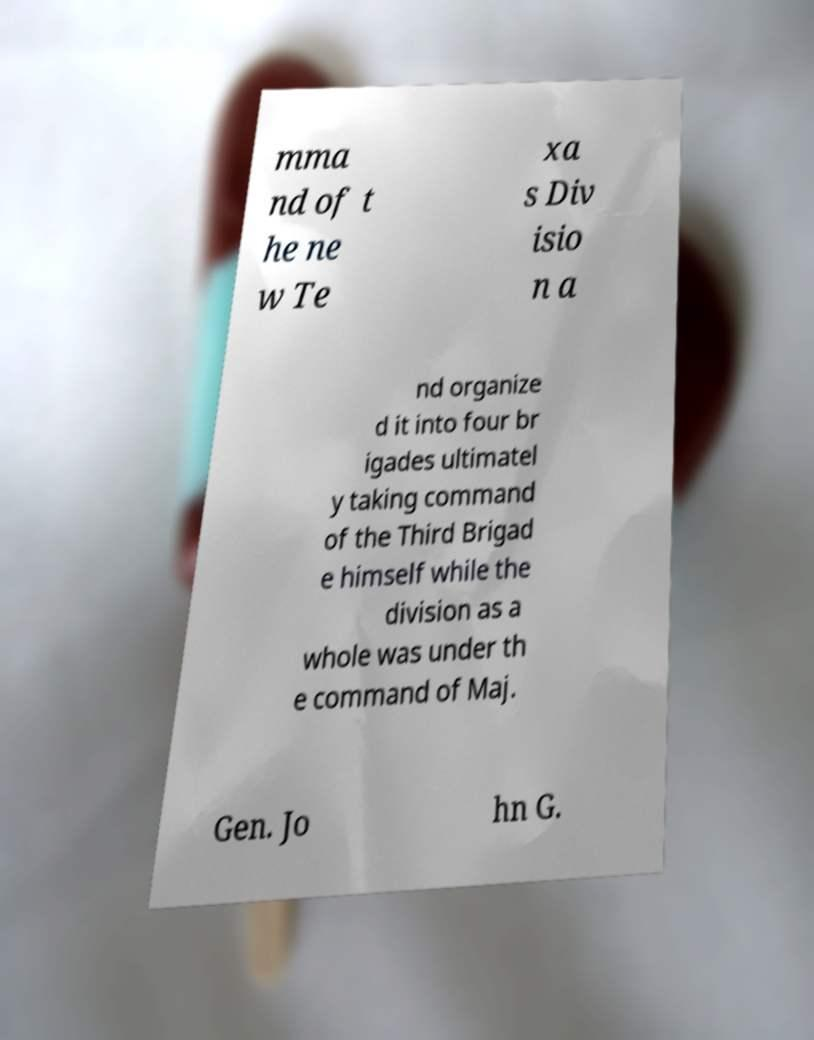Please read and relay the text visible in this image. What does it say? mma nd of t he ne w Te xa s Div isio n a nd organize d it into four br igades ultimatel y taking command of the Third Brigad e himself while the division as a whole was under th e command of Maj. Gen. Jo hn G. 